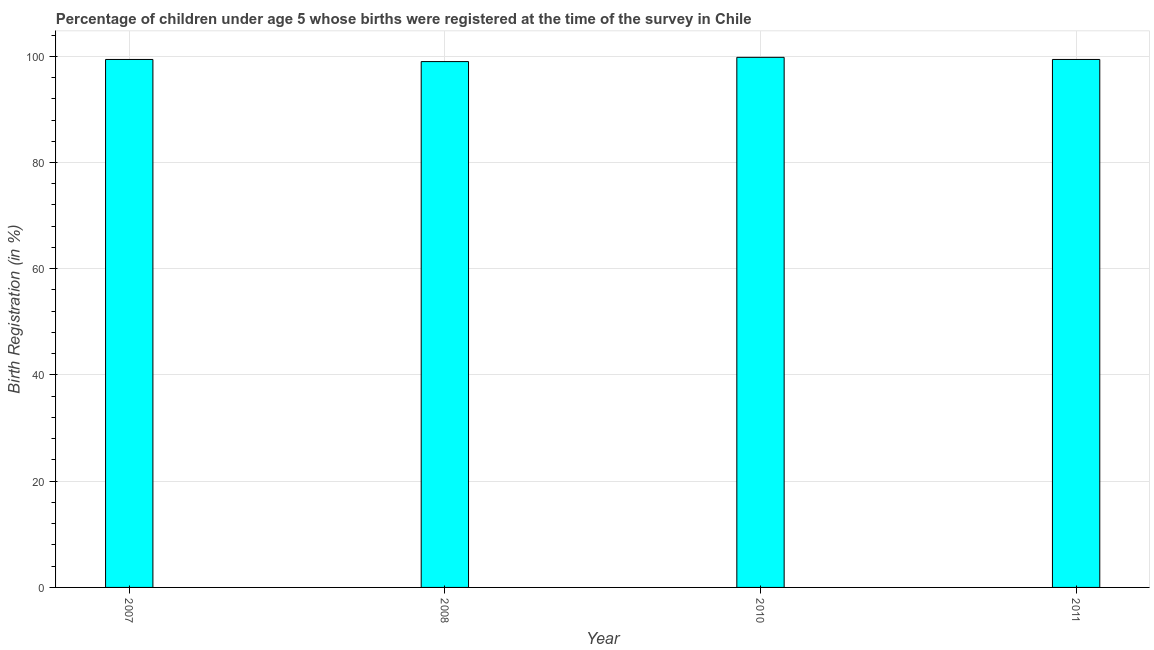Does the graph contain any zero values?
Your response must be concise. No. What is the title of the graph?
Offer a very short reply. Percentage of children under age 5 whose births were registered at the time of the survey in Chile. What is the label or title of the Y-axis?
Give a very brief answer. Birth Registration (in %). What is the birth registration in 2007?
Give a very brief answer. 99.4. Across all years, what is the maximum birth registration?
Offer a very short reply. 99.8. Across all years, what is the minimum birth registration?
Keep it short and to the point. 99. In which year was the birth registration minimum?
Keep it short and to the point. 2008. What is the sum of the birth registration?
Your response must be concise. 397.6. What is the difference between the birth registration in 2008 and 2010?
Keep it short and to the point. -0.8. What is the average birth registration per year?
Offer a terse response. 99.4. What is the median birth registration?
Offer a very short reply. 99.4. Do a majority of the years between 2008 and 2007 (inclusive) have birth registration greater than 84 %?
Your response must be concise. No. Is the difference between the birth registration in 2007 and 2008 greater than the difference between any two years?
Ensure brevity in your answer.  No. What is the difference between the highest and the second highest birth registration?
Your answer should be very brief. 0.4. What is the difference between the highest and the lowest birth registration?
Your answer should be compact. 0.8. Are all the bars in the graph horizontal?
Keep it short and to the point. No. What is the difference between two consecutive major ticks on the Y-axis?
Your answer should be very brief. 20. What is the Birth Registration (in %) in 2007?
Keep it short and to the point. 99.4. What is the Birth Registration (in %) of 2010?
Your response must be concise. 99.8. What is the Birth Registration (in %) of 2011?
Keep it short and to the point. 99.4. What is the difference between the Birth Registration (in %) in 2007 and 2008?
Your answer should be very brief. 0.4. What is the difference between the Birth Registration (in %) in 2007 and 2011?
Give a very brief answer. 0. What is the difference between the Birth Registration (in %) in 2008 and 2010?
Provide a short and direct response. -0.8. What is the difference between the Birth Registration (in %) in 2010 and 2011?
Provide a short and direct response. 0.4. What is the ratio of the Birth Registration (in %) in 2007 to that in 2008?
Your response must be concise. 1. What is the ratio of the Birth Registration (in %) in 2007 to that in 2011?
Your answer should be compact. 1. What is the ratio of the Birth Registration (in %) in 2008 to that in 2010?
Your answer should be compact. 0.99. 